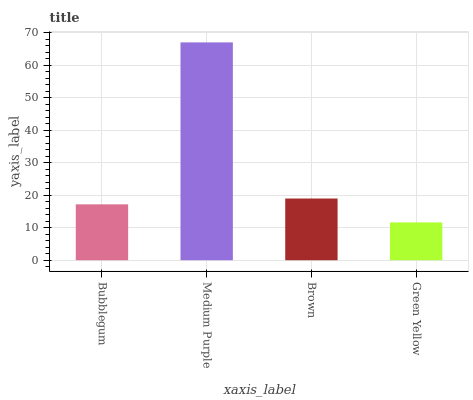Is Green Yellow the minimum?
Answer yes or no. Yes. Is Medium Purple the maximum?
Answer yes or no. Yes. Is Brown the minimum?
Answer yes or no. No. Is Brown the maximum?
Answer yes or no. No. Is Medium Purple greater than Brown?
Answer yes or no. Yes. Is Brown less than Medium Purple?
Answer yes or no. Yes. Is Brown greater than Medium Purple?
Answer yes or no. No. Is Medium Purple less than Brown?
Answer yes or no. No. Is Brown the high median?
Answer yes or no. Yes. Is Bubblegum the low median?
Answer yes or no. Yes. Is Bubblegum the high median?
Answer yes or no. No. Is Medium Purple the low median?
Answer yes or no. No. 